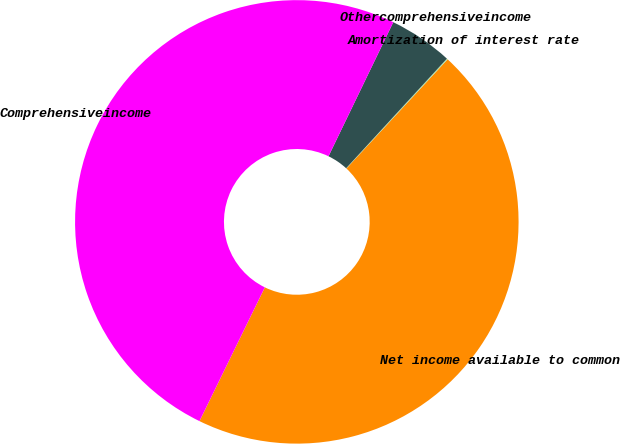<chart> <loc_0><loc_0><loc_500><loc_500><pie_chart><fcel>Net income available to common<fcel>Amortization of interest rate<fcel>Othercomprehensiveincome<fcel>Comprehensiveincome<nl><fcel>45.33%<fcel>0.07%<fcel>4.67%<fcel>49.93%<nl></chart> 